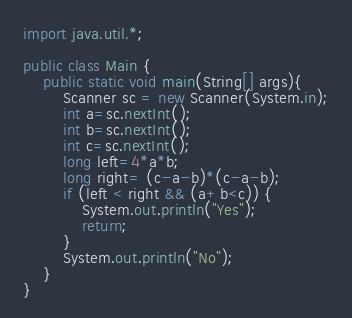<code> <loc_0><loc_0><loc_500><loc_500><_Java_>import java.util.*;

public class Main {
    public static void main(String[] args){
        Scanner sc = new Scanner(System.in);
        int a=sc.nextInt();
        int b=sc.nextInt();
        int c=sc.nextInt();
        long left=4*a*b;
        long right= (c-a-b)*(c-a-b);
        if (left < right && (a+b<c)) {
            System.out.println("Yes");
            return;
        }
        System.out.println("No");
    }
}</code> 